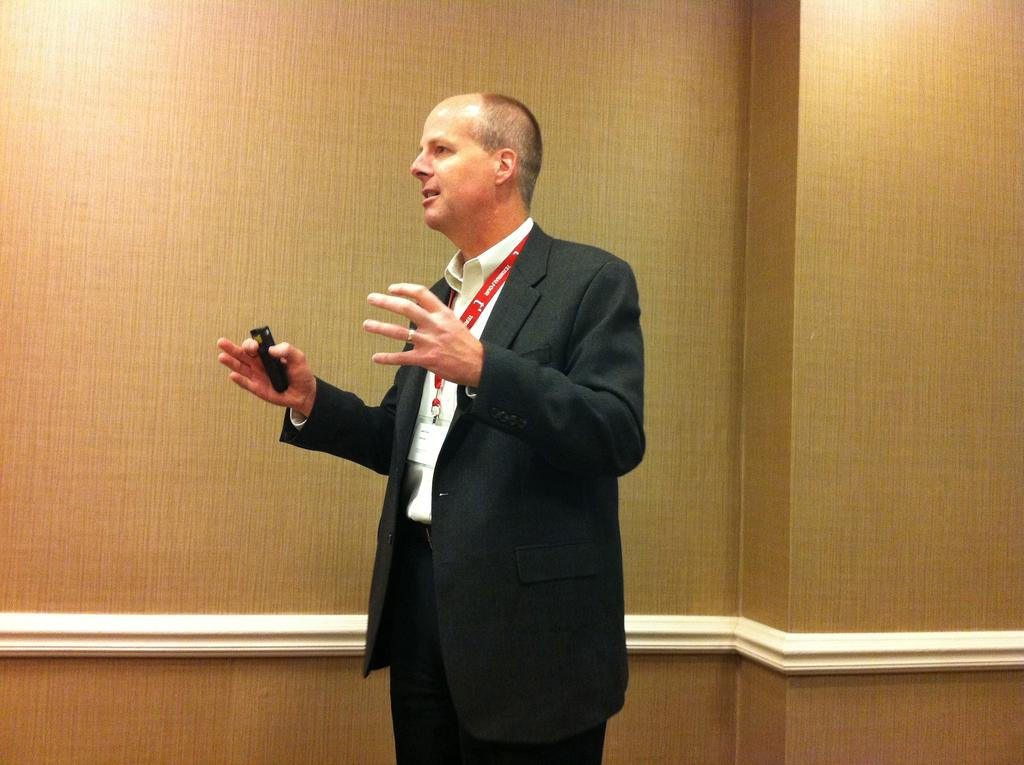Who is the main subject in the image? There is a person in the center of the image. What is the person wearing? The person is wearing a suit. What is the person holding in the image? The person is holding an object. What is the person's posture in the image? The person is standing. What can be seen in the background of the image? There is a wall in the background of the image. What type of fire can be seen in the image? There is no fire present in the image. What is the person using to carry the object in the image? The person is not using a tray to carry the object in the image. 